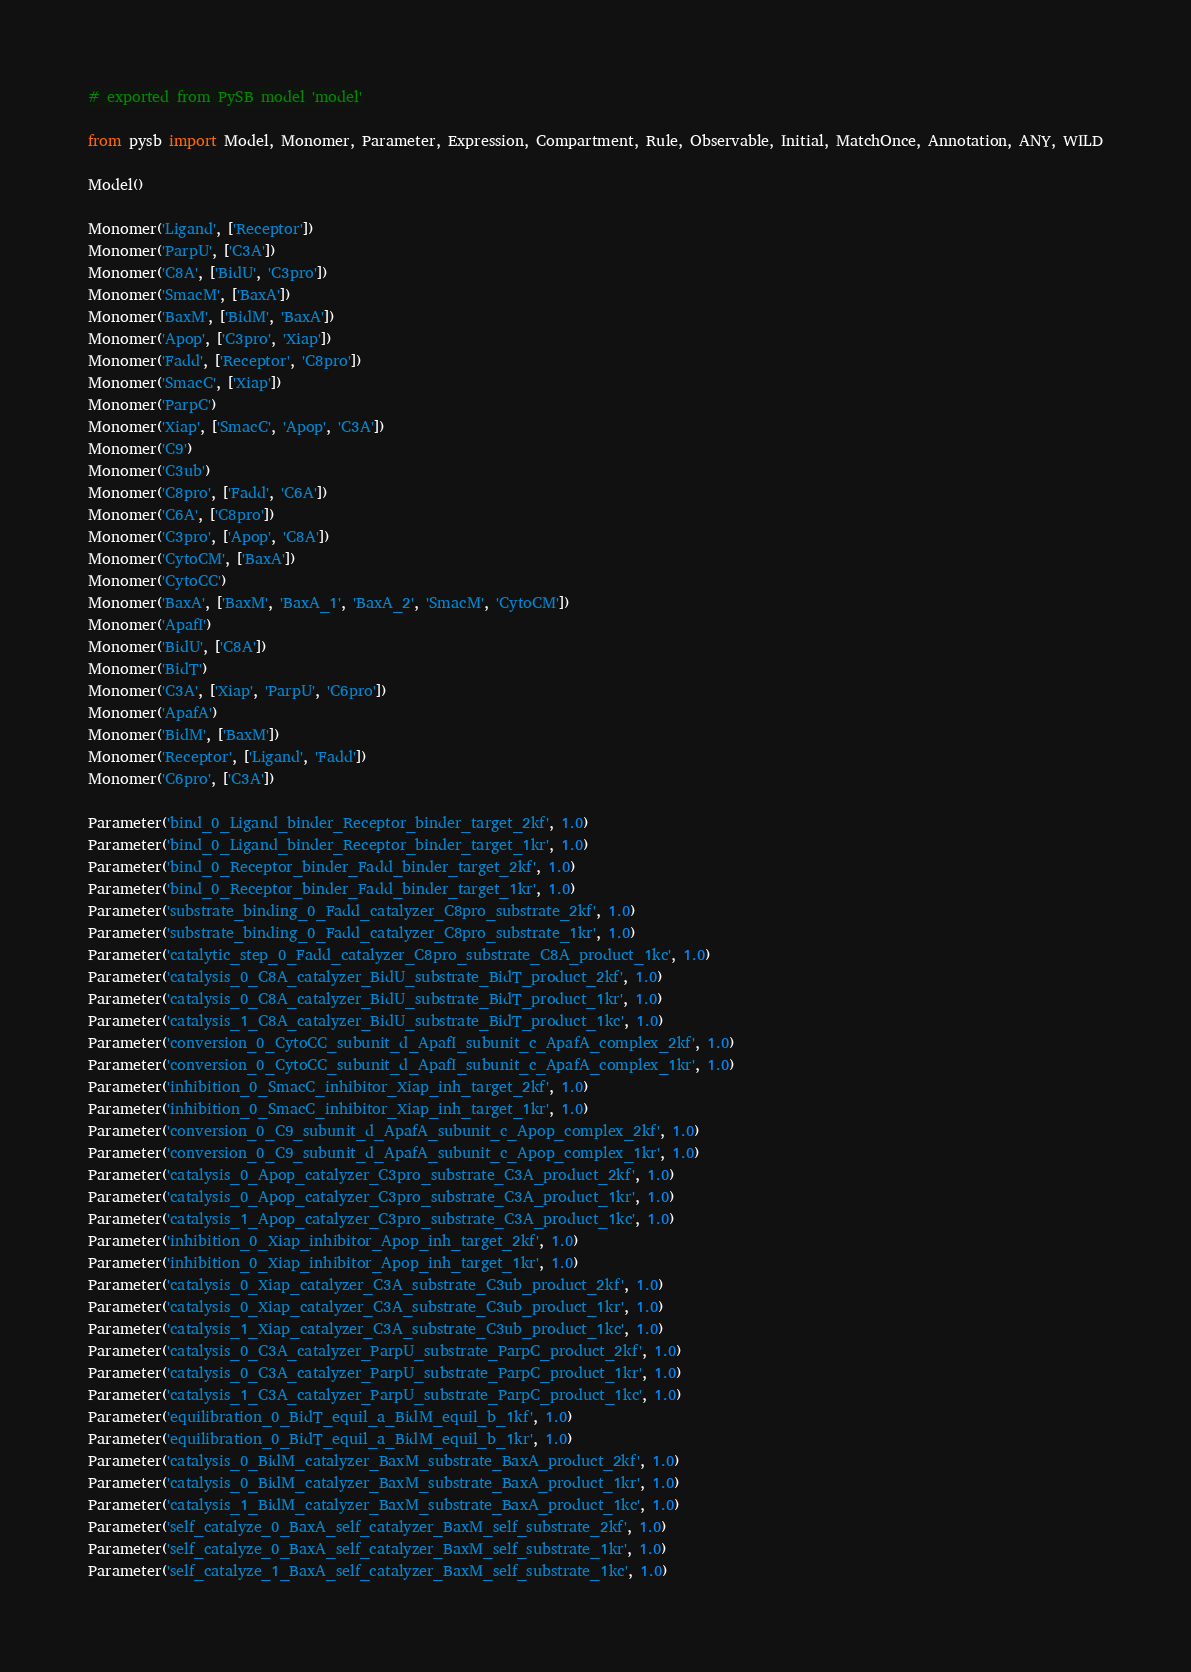<code> <loc_0><loc_0><loc_500><loc_500><_Python_># exported from PySB model 'model'

from pysb import Model, Monomer, Parameter, Expression, Compartment, Rule, Observable, Initial, MatchOnce, Annotation, ANY, WILD

Model()

Monomer('Ligand', ['Receptor'])
Monomer('ParpU', ['C3A'])
Monomer('C8A', ['BidU', 'C3pro'])
Monomer('SmacM', ['BaxA'])
Monomer('BaxM', ['BidM', 'BaxA'])
Monomer('Apop', ['C3pro', 'Xiap'])
Monomer('Fadd', ['Receptor', 'C8pro'])
Monomer('SmacC', ['Xiap'])
Monomer('ParpC')
Monomer('Xiap', ['SmacC', 'Apop', 'C3A'])
Monomer('C9')
Monomer('C3ub')
Monomer('C8pro', ['Fadd', 'C6A'])
Monomer('C6A', ['C8pro'])
Monomer('C3pro', ['Apop', 'C8A'])
Monomer('CytoCM', ['BaxA'])
Monomer('CytoCC')
Monomer('BaxA', ['BaxM', 'BaxA_1', 'BaxA_2', 'SmacM', 'CytoCM'])
Monomer('ApafI')
Monomer('BidU', ['C8A'])
Monomer('BidT')
Monomer('C3A', ['Xiap', 'ParpU', 'C6pro'])
Monomer('ApafA')
Monomer('BidM', ['BaxM'])
Monomer('Receptor', ['Ligand', 'Fadd'])
Monomer('C6pro', ['C3A'])

Parameter('bind_0_Ligand_binder_Receptor_binder_target_2kf', 1.0)
Parameter('bind_0_Ligand_binder_Receptor_binder_target_1kr', 1.0)
Parameter('bind_0_Receptor_binder_Fadd_binder_target_2kf', 1.0)
Parameter('bind_0_Receptor_binder_Fadd_binder_target_1kr', 1.0)
Parameter('substrate_binding_0_Fadd_catalyzer_C8pro_substrate_2kf', 1.0)
Parameter('substrate_binding_0_Fadd_catalyzer_C8pro_substrate_1kr', 1.0)
Parameter('catalytic_step_0_Fadd_catalyzer_C8pro_substrate_C8A_product_1kc', 1.0)
Parameter('catalysis_0_C8A_catalyzer_BidU_substrate_BidT_product_2kf', 1.0)
Parameter('catalysis_0_C8A_catalyzer_BidU_substrate_BidT_product_1kr', 1.0)
Parameter('catalysis_1_C8A_catalyzer_BidU_substrate_BidT_product_1kc', 1.0)
Parameter('conversion_0_CytoCC_subunit_d_ApafI_subunit_c_ApafA_complex_2kf', 1.0)
Parameter('conversion_0_CytoCC_subunit_d_ApafI_subunit_c_ApafA_complex_1kr', 1.0)
Parameter('inhibition_0_SmacC_inhibitor_Xiap_inh_target_2kf', 1.0)
Parameter('inhibition_0_SmacC_inhibitor_Xiap_inh_target_1kr', 1.0)
Parameter('conversion_0_C9_subunit_d_ApafA_subunit_c_Apop_complex_2kf', 1.0)
Parameter('conversion_0_C9_subunit_d_ApafA_subunit_c_Apop_complex_1kr', 1.0)
Parameter('catalysis_0_Apop_catalyzer_C3pro_substrate_C3A_product_2kf', 1.0)
Parameter('catalysis_0_Apop_catalyzer_C3pro_substrate_C3A_product_1kr', 1.0)
Parameter('catalysis_1_Apop_catalyzer_C3pro_substrate_C3A_product_1kc', 1.0)
Parameter('inhibition_0_Xiap_inhibitor_Apop_inh_target_2kf', 1.0)
Parameter('inhibition_0_Xiap_inhibitor_Apop_inh_target_1kr', 1.0)
Parameter('catalysis_0_Xiap_catalyzer_C3A_substrate_C3ub_product_2kf', 1.0)
Parameter('catalysis_0_Xiap_catalyzer_C3A_substrate_C3ub_product_1kr', 1.0)
Parameter('catalysis_1_Xiap_catalyzer_C3A_substrate_C3ub_product_1kc', 1.0)
Parameter('catalysis_0_C3A_catalyzer_ParpU_substrate_ParpC_product_2kf', 1.0)
Parameter('catalysis_0_C3A_catalyzer_ParpU_substrate_ParpC_product_1kr', 1.0)
Parameter('catalysis_1_C3A_catalyzer_ParpU_substrate_ParpC_product_1kc', 1.0)
Parameter('equilibration_0_BidT_equil_a_BidM_equil_b_1kf', 1.0)
Parameter('equilibration_0_BidT_equil_a_BidM_equil_b_1kr', 1.0)
Parameter('catalysis_0_BidM_catalyzer_BaxM_substrate_BaxA_product_2kf', 1.0)
Parameter('catalysis_0_BidM_catalyzer_BaxM_substrate_BaxA_product_1kr', 1.0)
Parameter('catalysis_1_BidM_catalyzer_BaxM_substrate_BaxA_product_1kc', 1.0)
Parameter('self_catalyze_0_BaxA_self_catalyzer_BaxM_self_substrate_2kf', 1.0)
Parameter('self_catalyze_0_BaxA_self_catalyzer_BaxM_self_substrate_1kr', 1.0)
Parameter('self_catalyze_1_BaxA_self_catalyzer_BaxM_self_substrate_1kc', 1.0)</code> 